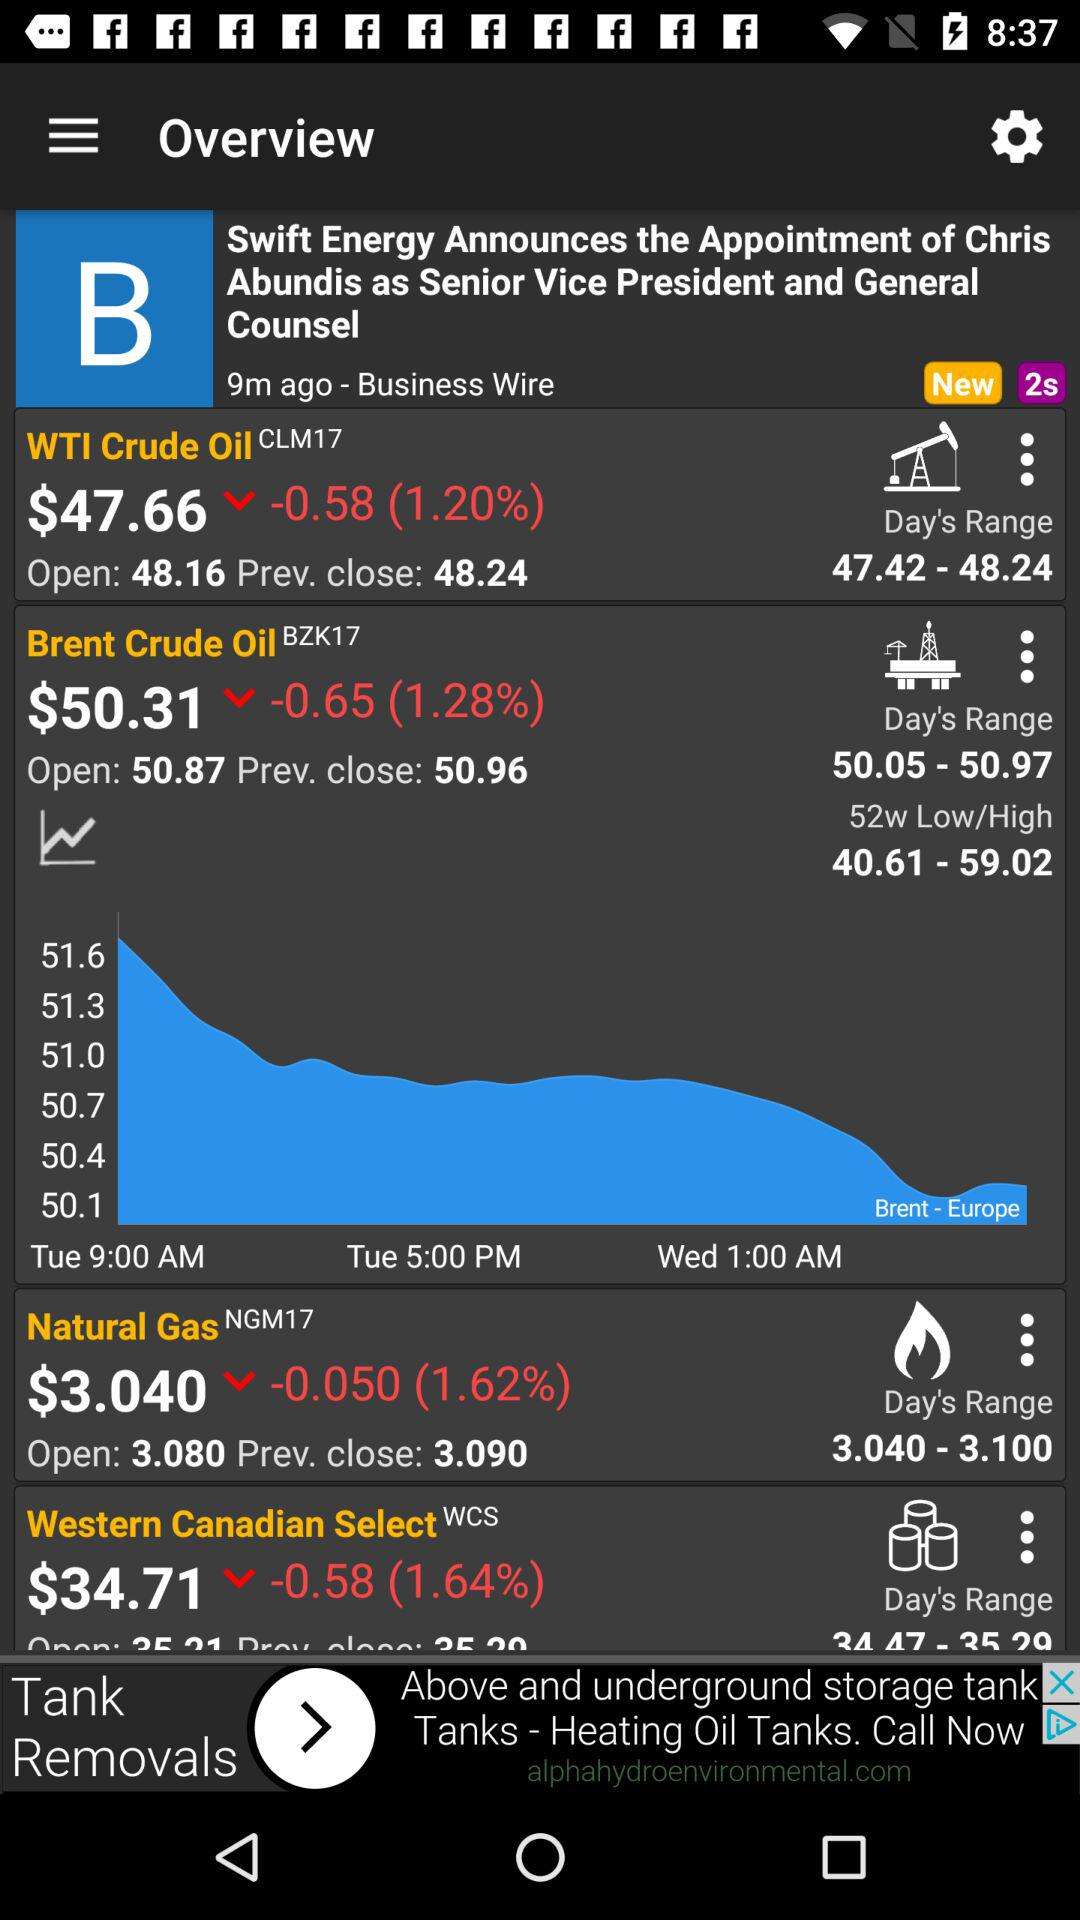What is the opening price of "Brent Crude Oil"? The opening price of "Brent Crude Oil" is $50.87. 